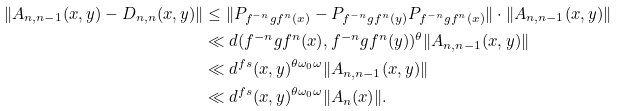Convert formula to latex. <formula><loc_0><loc_0><loc_500><loc_500>\| A _ { n , n - 1 } ( x , y ) - D _ { n , n } ( x , y ) \| & \leq \| P _ { f ^ { - n } g f ^ { n } ( x ) } - P _ { f ^ { - n } g f ^ { n } ( y ) } P _ { f ^ { - n } g f ^ { n } ( x ) } \| \cdot \| A _ { n , n - 1 } ( x , y ) \| \\ & \ll d ( f ^ { - n } g f ^ { n } ( x ) , f ^ { - n } g f ^ { n } ( y ) ) ^ { \theta } \| A _ { n , n - 1 } ( x , y ) \| \\ & \ll d ^ { f s } ( x , y ) ^ { \theta \omega _ { 0 } \omega } \| A _ { n , n - 1 } ( x , y ) \| \\ & \ll d ^ { f s } ( x , y ) ^ { \theta \omega _ { 0 } \omega } \| A _ { n } ( x ) \| .</formula> 